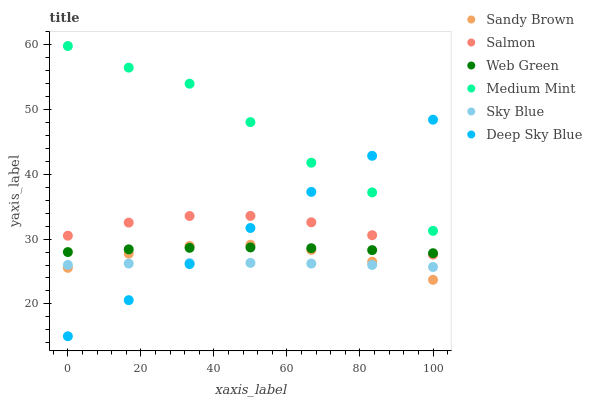Does Sky Blue have the minimum area under the curve?
Answer yes or no. Yes. Does Medium Mint have the maximum area under the curve?
Answer yes or no. Yes. Does Salmon have the minimum area under the curve?
Answer yes or no. No. Does Salmon have the maximum area under the curve?
Answer yes or no. No. Is Deep Sky Blue the smoothest?
Answer yes or no. Yes. Is Medium Mint the roughest?
Answer yes or no. Yes. Is Salmon the smoothest?
Answer yes or no. No. Is Salmon the roughest?
Answer yes or no. No. Does Deep Sky Blue have the lowest value?
Answer yes or no. Yes. Does Salmon have the lowest value?
Answer yes or no. No. Does Medium Mint have the highest value?
Answer yes or no. Yes. Does Salmon have the highest value?
Answer yes or no. No. Is Sky Blue less than Medium Mint?
Answer yes or no. Yes. Is Medium Mint greater than Sky Blue?
Answer yes or no. Yes. Does Deep Sky Blue intersect Salmon?
Answer yes or no. Yes. Is Deep Sky Blue less than Salmon?
Answer yes or no. No. Is Deep Sky Blue greater than Salmon?
Answer yes or no. No. Does Sky Blue intersect Medium Mint?
Answer yes or no. No. 